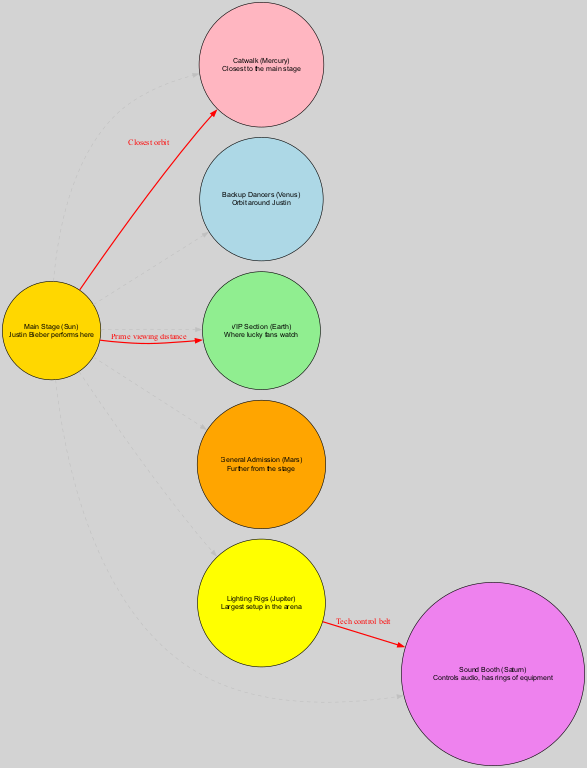What is the name of the central object? The central object is the "Main Stage (Sun)" where Justin Bieber performs. This is clearly labeled in the diagram as the central focus point.
Answer: Main Stage (Sun) How many orbiting objects are there? The diagram lists six orbiting objects: Catwalk, Backup Dancers, VIP Section, General Admission, Lighting Rigs, and Sound Booth. By counting each labeled orbiting object, we find that there are six.
Answer: 6 Which orbiting object is closest to the main stage? The closest orbiting object to the main stage is labeled "Catwalk (Mercury)." The diagram provides a direct connection indicating this relationship.
Answer: Catwalk (Mercury) What is the description of the VIP section? The description of the VIP section is "Where lucky fans watch." This detail can be found in the label for the VIP Section node in the diagram.
Answer: Where lucky fans watch What do the lighting rigs connect to? The lighting rigs (Jupiter) connect to the sound booth (Saturn) as indicated by the labeled edge between these two objects.
Answer: Sound Booth (Saturn) Which orbital object is labeled as "Further from the stage"? The orbital object labeled as "Further from the stage" is the General Admission (Mars). This description directly corresponds to its position in relation to the main stage in the diagram.
Answer: General Admission (Mars) What color is used for the main stage? The main stage is colored gold, as specified in the node's attributes in the diagram. This is clearly depicted in the visual representation.
Answer: Gold What connects the main stage to the VIP section? The connection from the main stage to the VIP section is labeled "Prime viewing distance," indicating the relationship between these two nodes in the diagram.
Answer: Prime viewing distance How many edges are shown in the diagram? There are five edges in total connecting the central object and the orbiting objects, along with the connection from the lighting rigs to the sound booth. By analyzing the connections, we reach the total of five edges.
Answer: 5 